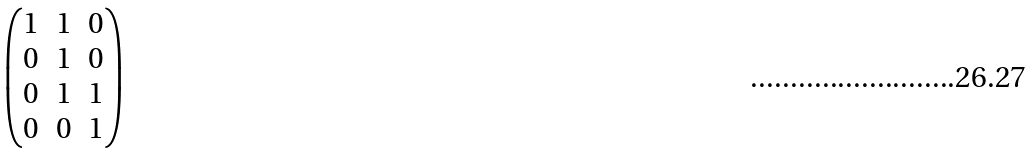Convert formula to latex. <formula><loc_0><loc_0><loc_500><loc_500>\begin{pmatrix} 1 & 1 & 0 \\ 0 & 1 & 0 \\ 0 & 1 & 1 \\ 0 & 0 & 1 \end{pmatrix}</formula> 